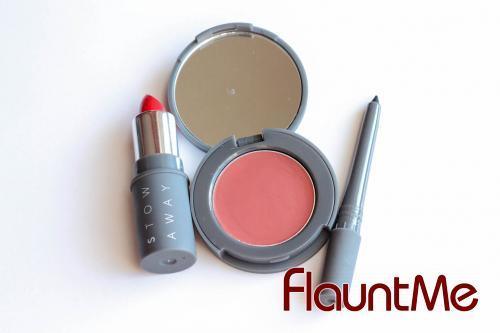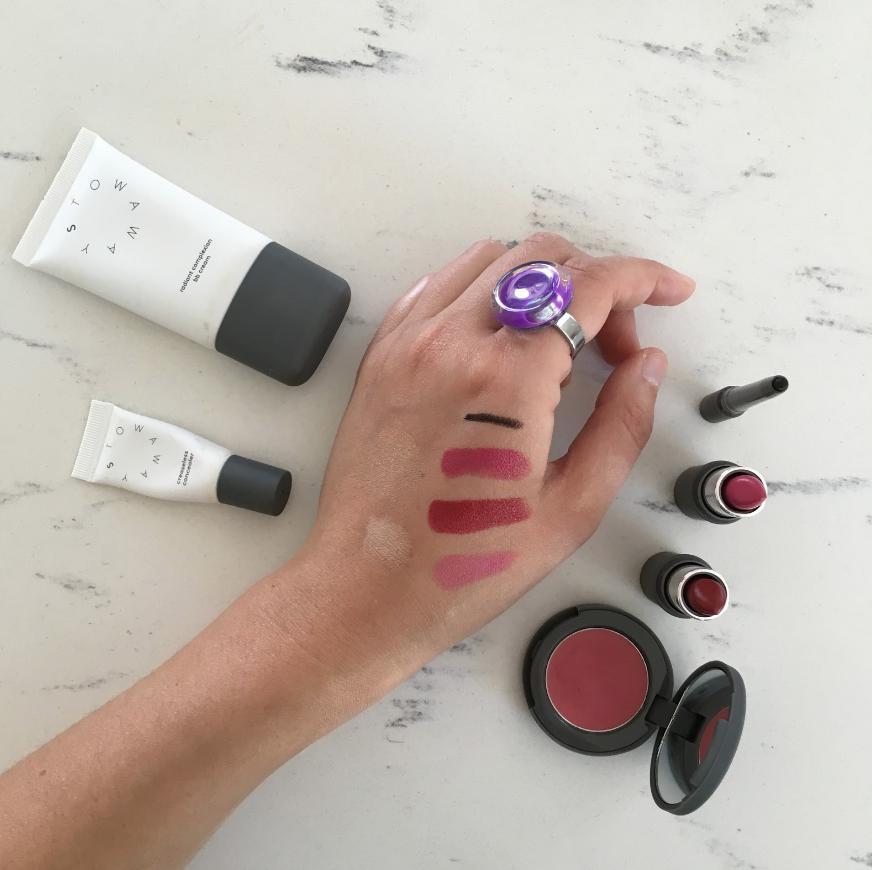The first image is the image on the left, the second image is the image on the right. Given the left and right images, does the statement "The image on the right contains an opened jar with lid." hold true? Answer yes or no. No. 